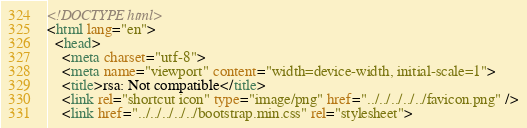<code> <loc_0><loc_0><loc_500><loc_500><_HTML_><!DOCTYPE html>
<html lang="en">
  <head>
    <meta charset="utf-8">
    <meta name="viewport" content="width=device-width, initial-scale=1">
    <title>rsa: Not compatible</title>
    <link rel="shortcut icon" type="image/png" href="../../../../../favicon.png" />
    <link href="../../../../../bootstrap.min.css" rel="stylesheet"></code> 